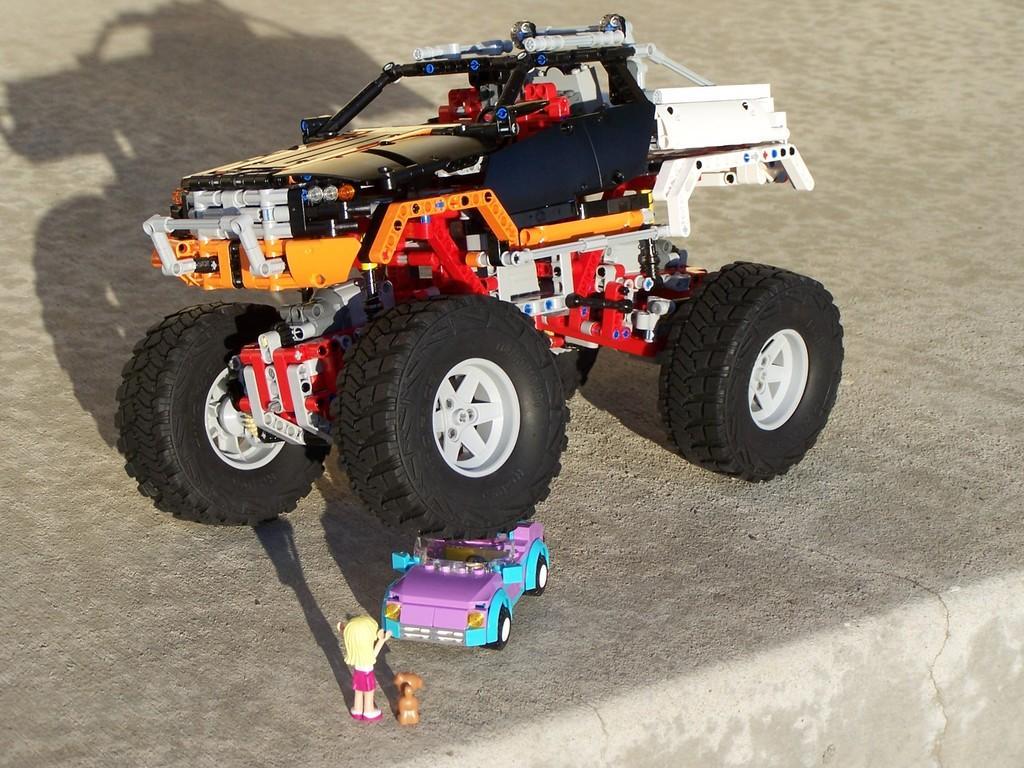Can you describe this image briefly? In this image we can see toys on a surface. 